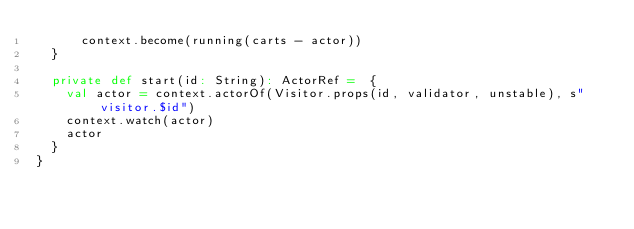<code> <loc_0><loc_0><loc_500><loc_500><_Scala_>      context.become(running(carts - actor))
  }

  private def start(id: String): ActorRef =  {
    val actor = context.actorOf(Visitor.props(id, validator, unstable), s"visitor.$id")
    context.watch(actor)
    actor
  }
}
</code> 